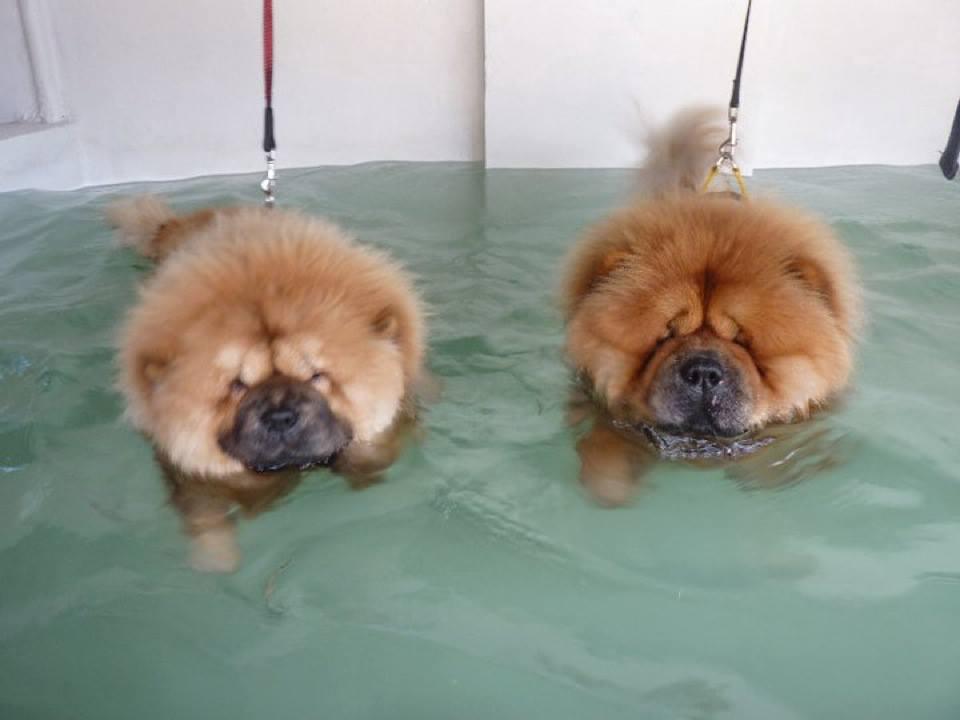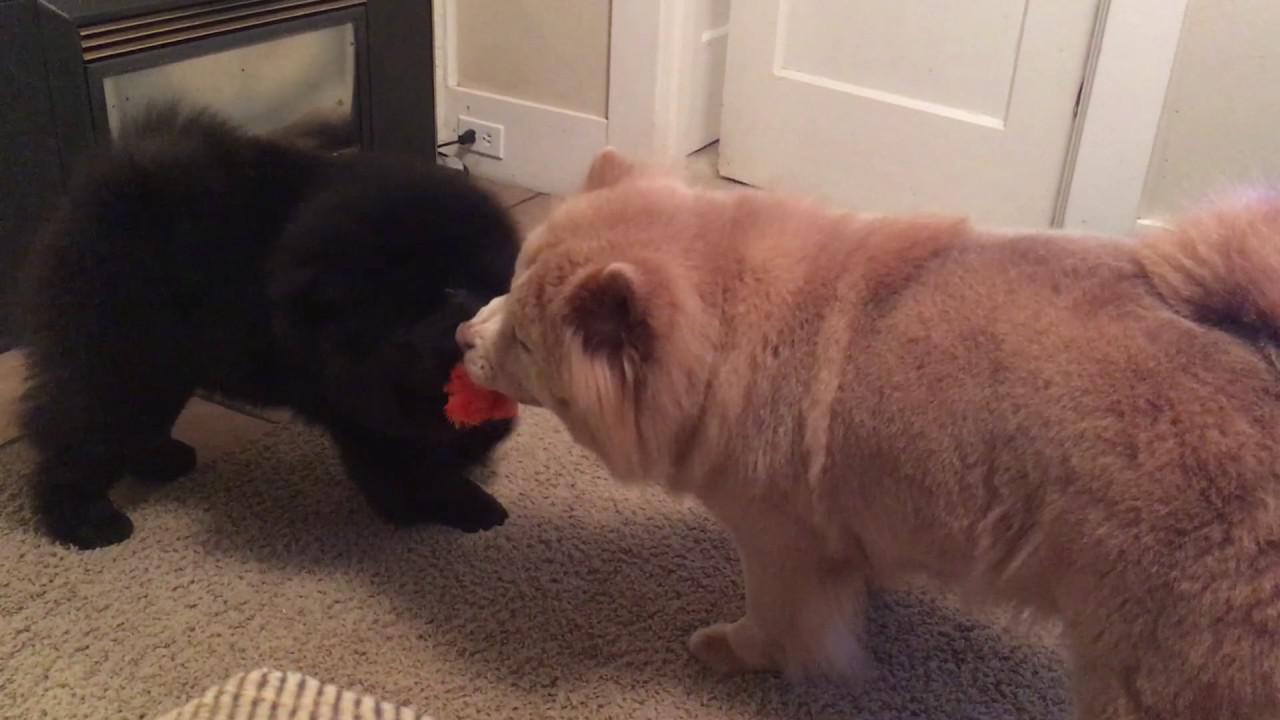The first image is the image on the left, the second image is the image on the right. Examine the images to the left and right. Is the description "One of the dogs has something in its mouth." accurate? Answer yes or no. Yes. The first image is the image on the left, the second image is the image on the right. For the images displayed, is the sentence "The image on the right has one dog with a toy in its mouth." factually correct? Answer yes or no. Yes. 